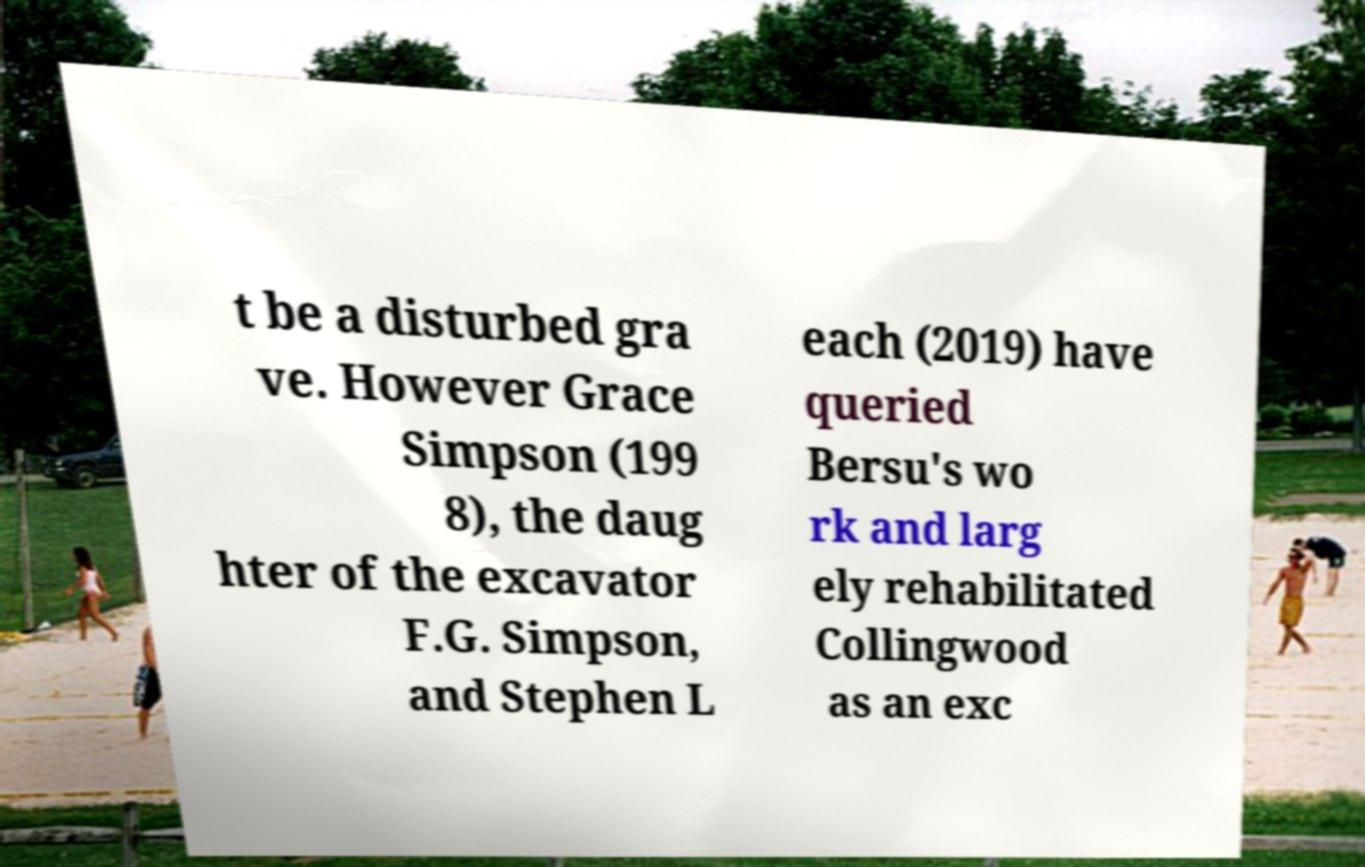There's text embedded in this image that I need extracted. Can you transcribe it verbatim? t be a disturbed gra ve. However Grace Simpson (199 8), the daug hter of the excavator F.G. Simpson, and Stephen L each (2019) have queried Bersu's wo rk and larg ely rehabilitated Collingwood as an exc 